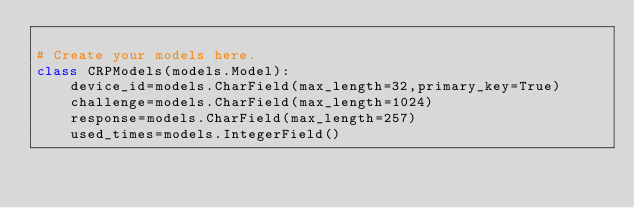Convert code to text. <code><loc_0><loc_0><loc_500><loc_500><_Python_>
# Create your models here.
class CRPModels(models.Model):
    device_id=models.CharField(max_length=32,primary_key=True)
    challenge=models.CharField(max_length=1024)
    response=models.CharField(max_length=257)
    used_times=models.IntegerField()
</code> 